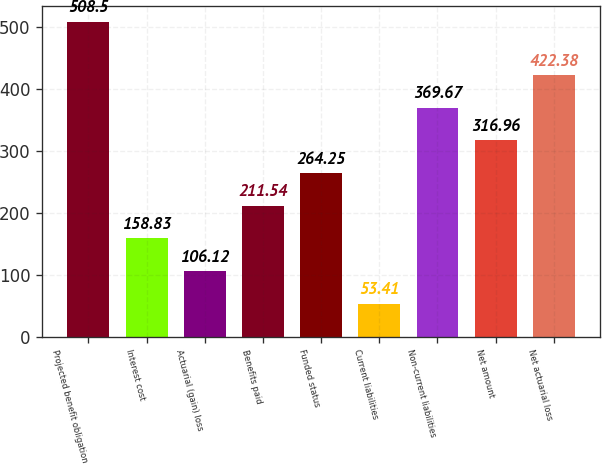<chart> <loc_0><loc_0><loc_500><loc_500><bar_chart><fcel>Projected benefit obligation<fcel>Interest cost<fcel>Actuarial (gain) loss<fcel>Benefits paid<fcel>Funded status<fcel>Current liabilities<fcel>Non-current liabilities<fcel>Net amount<fcel>Net actuarial loss<nl><fcel>508.5<fcel>158.83<fcel>106.12<fcel>211.54<fcel>264.25<fcel>53.41<fcel>369.67<fcel>316.96<fcel>422.38<nl></chart> 